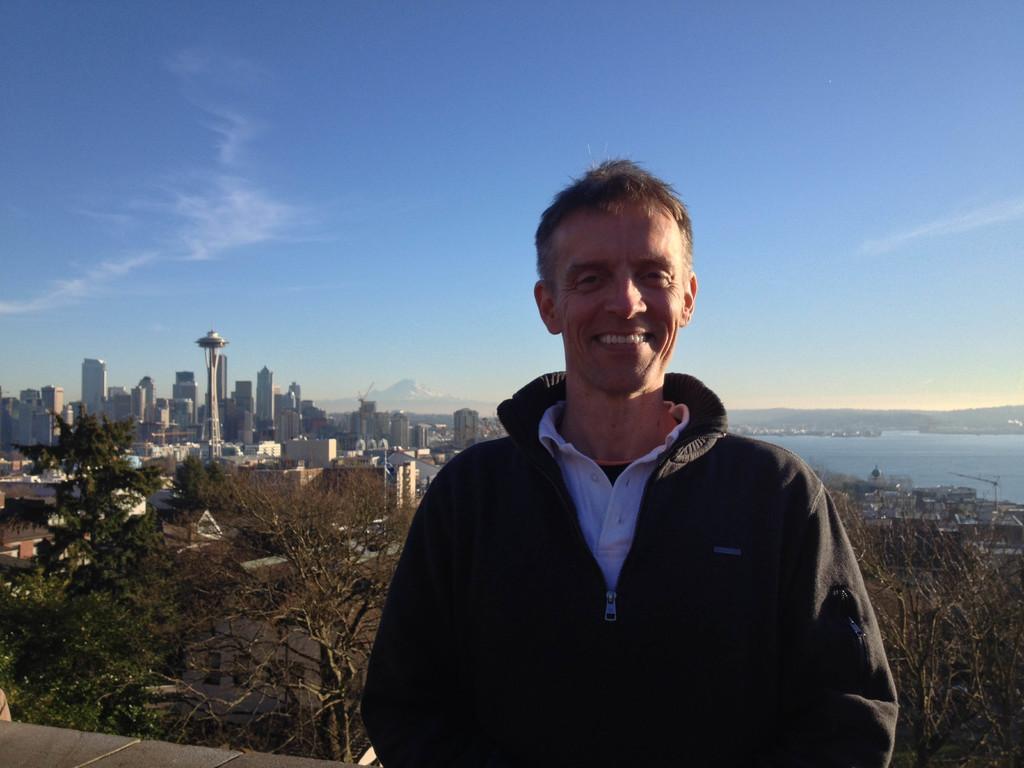Describe this image in one or two sentences. In this image there is a person, behind the person there are some trees, buildings, at the top there is the sky, on the right side there is the water, hill. 